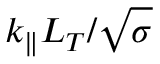<formula> <loc_0><loc_0><loc_500><loc_500>k _ { \| } L _ { T } / \sqrt { \sigma }</formula> 